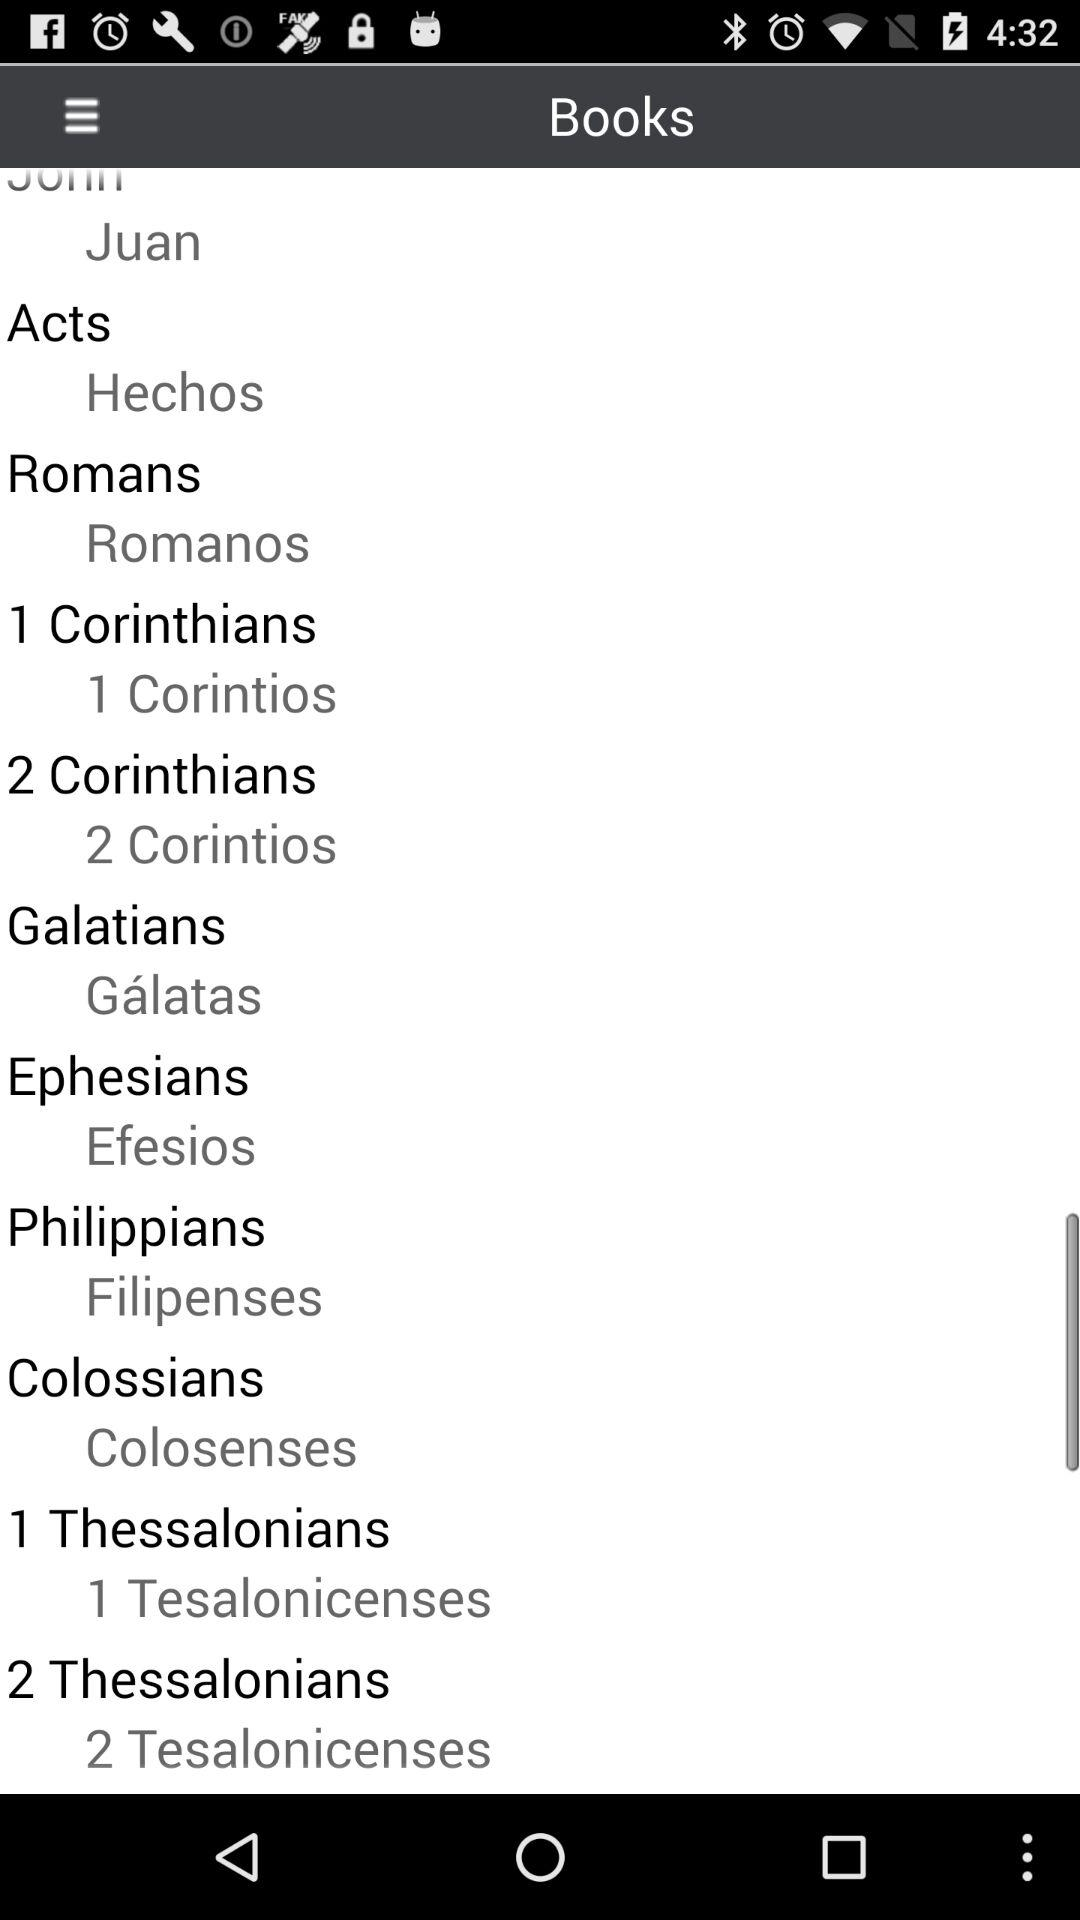What is the name of the "Philippians" book in Spanish? The name of the "Philippians" book in Spanish is "Filipenses". 